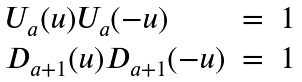Convert formula to latex. <formula><loc_0><loc_0><loc_500><loc_500>\begin{array} { l l l } { { U _ { a } ( u ) U _ { a } ( - u ) } } & { = } & { 1 } \\ { { D _ { a + 1 } ( u ) D _ { a + 1 } ( - u ) } } & { = } & { 1 } \end{array} \,</formula> 